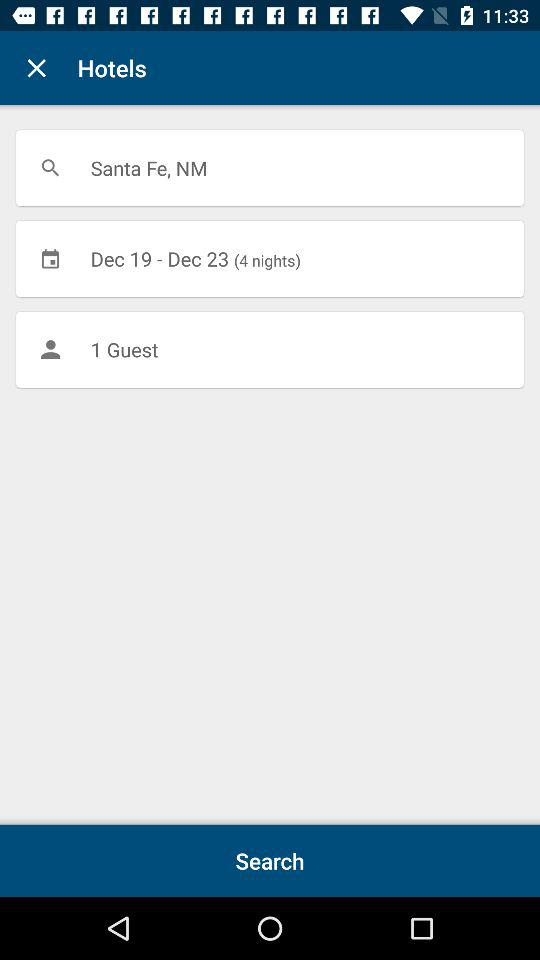The hotel is booked for which dates? The hotel is booked from December 19 to December 23. 